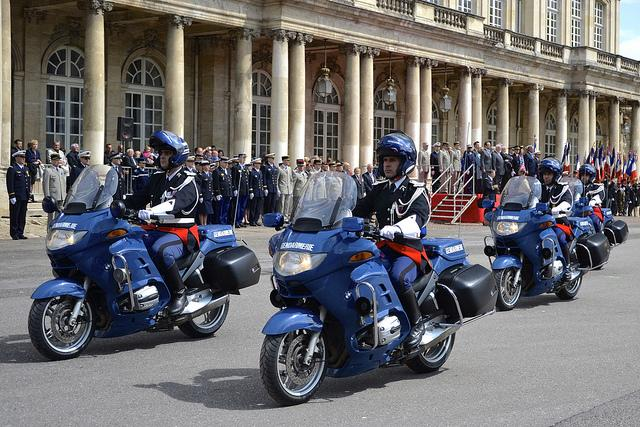What type of outfit are the men on the motorcycles wearing?

Choices:
A) beach wear
B) uniform
C) casual
D) sweatsuits uniform 